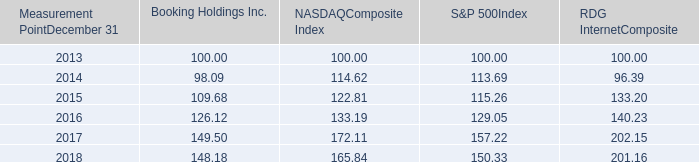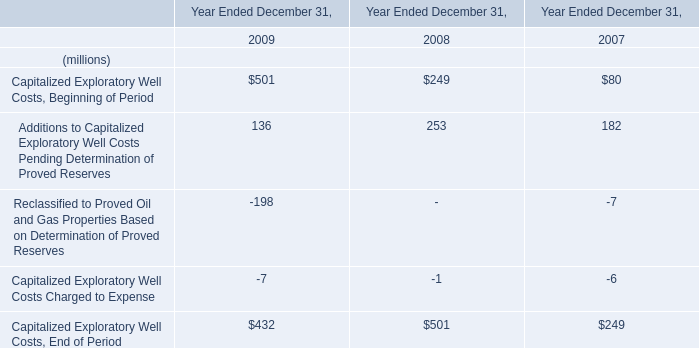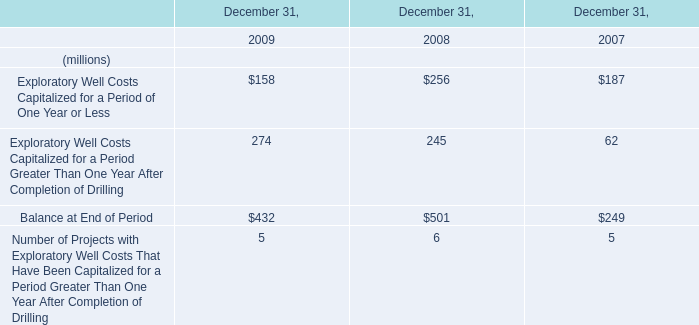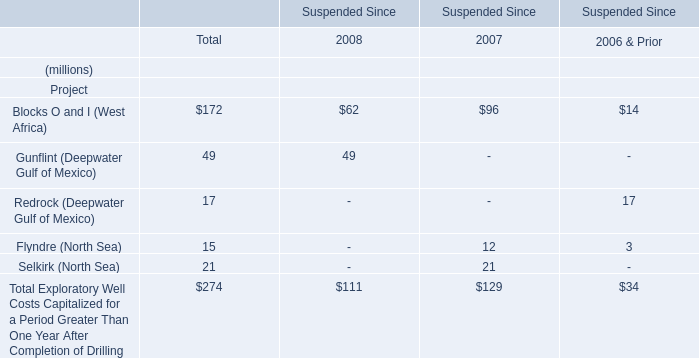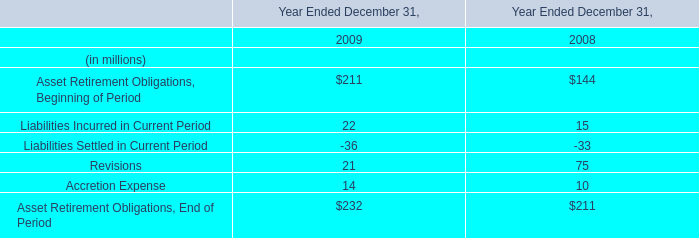What is the growing rate of Flyndre (North Sea) in the year with the most Blocks O and I (West Africa)? (in %) 
Computations: ((12 - 3) / 3)
Answer: 3.0. 